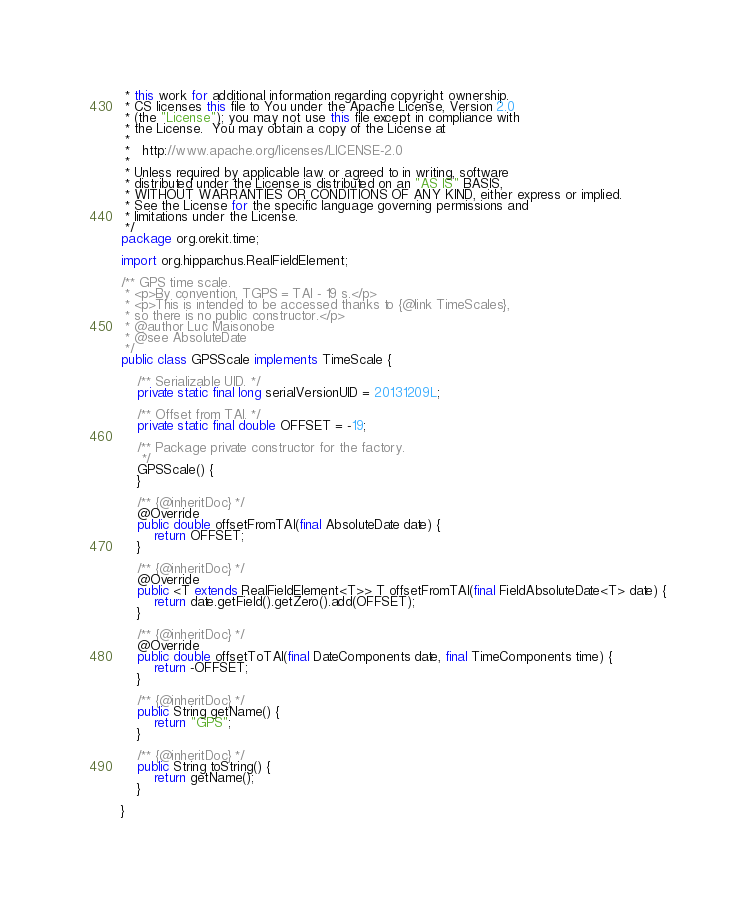<code> <loc_0><loc_0><loc_500><loc_500><_Java_> * this work for additional information regarding copyright ownership.
 * CS licenses this file to You under the Apache License, Version 2.0
 * (the "License"); you may not use this file except in compliance with
 * the License.  You may obtain a copy of the License at
 *
 *   http://www.apache.org/licenses/LICENSE-2.0
 *
 * Unless required by applicable law or agreed to in writing, software
 * distributed under the License is distributed on an "AS IS" BASIS,
 * WITHOUT WARRANTIES OR CONDITIONS OF ANY KIND, either express or implied.
 * See the License for the specific language governing permissions and
 * limitations under the License.
 */
package org.orekit.time;

import org.hipparchus.RealFieldElement;

/** GPS time scale.
 * <p>By convention, TGPS = TAI - 19 s.</p>
 * <p>This is intended to be accessed thanks to {@link TimeScales},
 * so there is no public constructor.</p>
 * @author Luc Maisonobe
 * @see AbsoluteDate
 */
public class GPSScale implements TimeScale {

    /** Serializable UID. */
    private static final long serialVersionUID = 20131209L;

    /** Offset from TAI. */
    private static final double OFFSET = -19;

    /** Package private constructor for the factory.
     */
    GPSScale() {
    }

    /** {@inheritDoc} */
    @Override
    public double offsetFromTAI(final AbsoluteDate date) {
        return OFFSET;
    }

    /** {@inheritDoc} */
    @Override
    public <T extends RealFieldElement<T>> T offsetFromTAI(final FieldAbsoluteDate<T> date) {
        return date.getField().getZero().add(OFFSET);
    }

    /** {@inheritDoc} */
    @Override
    public double offsetToTAI(final DateComponents date, final TimeComponents time) {
        return -OFFSET;
    }

    /** {@inheritDoc} */
    public String getName() {
        return "GPS";
    }

    /** {@inheritDoc} */
    public String toString() {
        return getName();
    }

}
</code> 